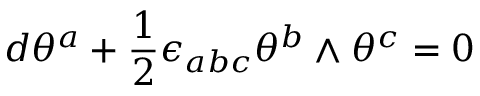Convert formula to latex. <formula><loc_0><loc_0><loc_500><loc_500>d \theta ^ { a } + { \frac { 1 } { 2 } } \epsilon _ { a b c } \theta ^ { b } \wedge \theta ^ { c } = 0</formula> 